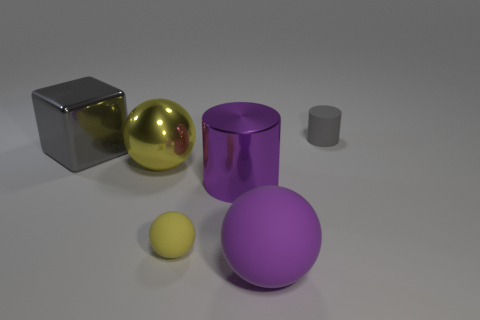Subtract all matte spheres. How many spheres are left? 1 Subtract all yellow cubes. How many yellow spheres are left? 2 Add 2 big cyan rubber balls. How many objects exist? 8 Subtract all cubes. How many objects are left? 5 Subtract all cyan spheres. Subtract all cyan cylinders. How many spheres are left? 3 Subtract all small yellow matte things. Subtract all big matte spheres. How many objects are left? 4 Add 1 metal objects. How many metal objects are left? 4 Add 3 purple things. How many purple things exist? 5 Subtract 1 yellow balls. How many objects are left? 5 